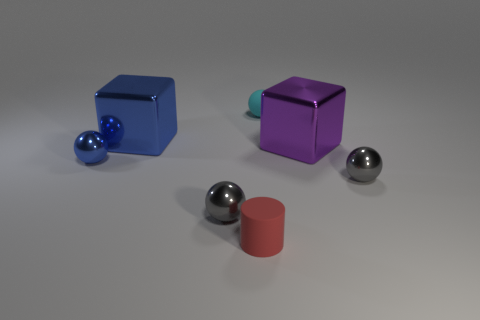Subtract all purple cubes. How many gray spheres are left? 2 Add 1 blue balls. How many objects exist? 8 Subtract all rubber balls. How many balls are left? 3 Subtract 2 spheres. How many spheres are left? 2 Subtract all blue spheres. How many spheres are left? 3 Subtract all blue balls. Subtract all cyan cubes. How many balls are left? 3 Subtract all cylinders. How many objects are left? 6 Add 1 tiny rubber spheres. How many tiny rubber spheres are left? 2 Add 4 small cylinders. How many small cylinders exist? 5 Subtract 0 gray cylinders. How many objects are left? 7 